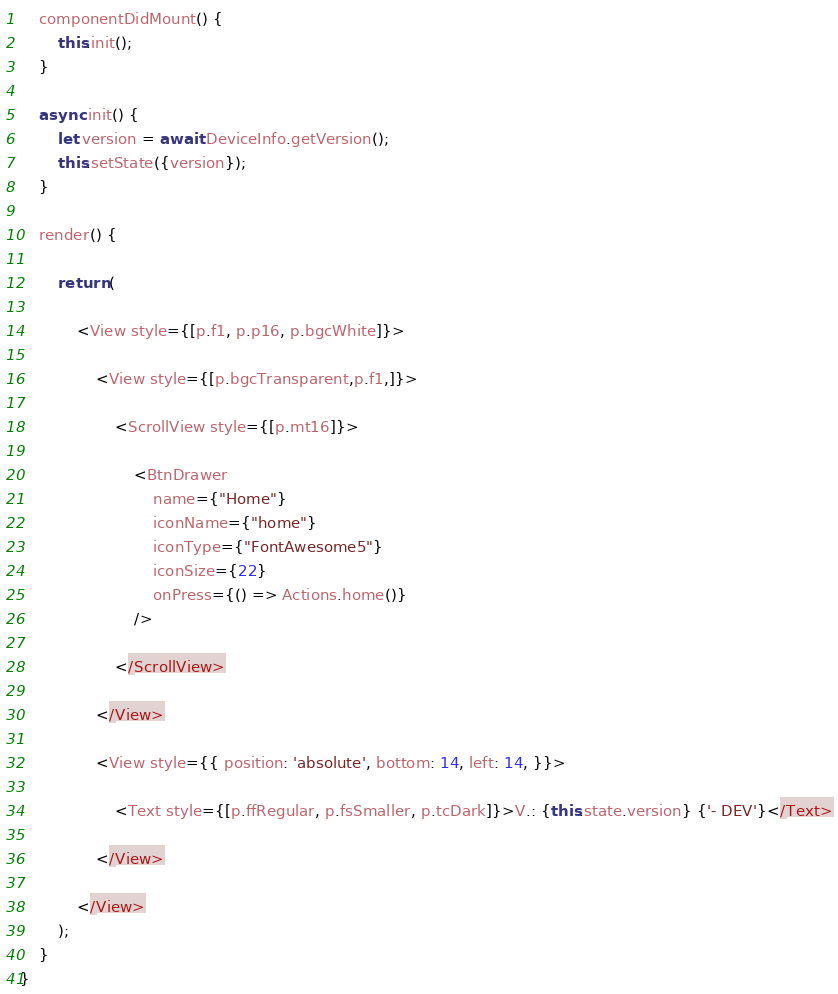<code> <loc_0><loc_0><loc_500><loc_500><_JavaScript_>	componentDidMount() {
		this.init();
	}
	
	async init() {
		let version = await DeviceInfo.getVersion();
		this.setState({version});
    }
    
    render() {

        return (

            <View style={[p.f1, p.p16, p.bgcWhite]}>

                <View style={[p.bgcTransparent,p.f1,]}>

                    <ScrollView style={[p.mt16]}>

                        <BtnDrawer
                            name={"Home"}
                            iconName={"home"} 
                            iconType={"FontAwesome5"}
                            iconSize={22}
                            onPress={() => Actions.home()}
                        />

                    </ScrollView>

                </View>

                <View style={{ position: 'absolute', bottom: 14, left: 14, }}>

                    <Text style={[p.ffRegular, p.fsSmaller, p.tcDark]}>V.: {this.state.version} {'- DEV'}</Text>

                </View>

            </View>
        );
    }
}
</code> 